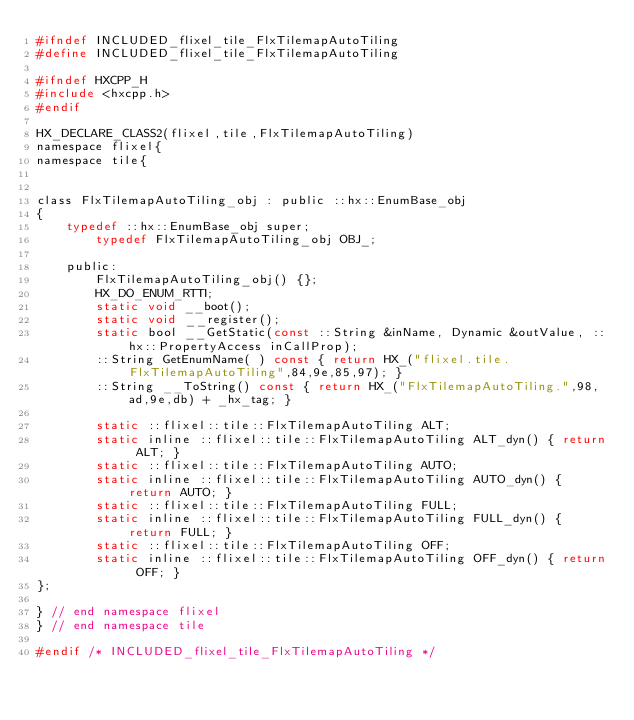<code> <loc_0><loc_0><loc_500><loc_500><_C_>#ifndef INCLUDED_flixel_tile_FlxTilemapAutoTiling
#define INCLUDED_flixel_tile_FlxTilemapAutoTiling

#ifndef HXCPP_H
#include <hxcpp.h>
#endif

HX_DECLARE_CLASS2(flixel,tile,FlxTilemapAutoTiling)
namespace flixel{
namespace tile{


class FlxTilemapAutoTiling_obj : public ::hx::EnumBase_obj
{
	typedef ::hx::EnumBase_obj super;
		typedef FlxTilemapAutoTiling_obj OBJ_;

	public:
		FlxTilemapAutoTiling_obj() {};
		HX_DO_ENUM_RTTI;
		static void __boot();
		static void __register();
		static bool __GetStatic(const ::String &inName, Dynamic &outValue, ::hx::PropertyAccess inCallProp);
		::String GetEnumName( ) const { return HX_("flixel.tile.FlxTilemapAutoTiling",84,9e,85,97); }
		::String __ToString() const { return HX_("FlxTilemapAutoTiling.",98,ad,9e,db) + _hx_tag; }

		static ::flixel::tile::FlxTilemapAutoTiling ALT;
		static inline ::flixel::tile::FlxTilemapAutoTiling ALT_dyn() { return ALT; }
		static ::flixel::tile::FlxTilemapAutoTiling AUTO;
		static inline ::flixel::tile::FlxTilemapAutoTiling AUTO_dyn() { return AUTO; }
		static ::flixel::tile::FlxTilemapAutoTiling FULL;
		static inline ::flixel::tile::FlxTilemapAutoTiling FULL_dyn() { return FULL; }
		static ::flixel::tile::FlxTilemapAutoTiling OFF;
		static inline ::flixel::tile::FlxTilemapAutoTiling OFF_dyn() { return OFF; }
};

} // end namespace flixel
} // end namespace tile

#endif /* INCLUDED_flixel_tile_FlxTilemapAutoTiling */ 
</code> 